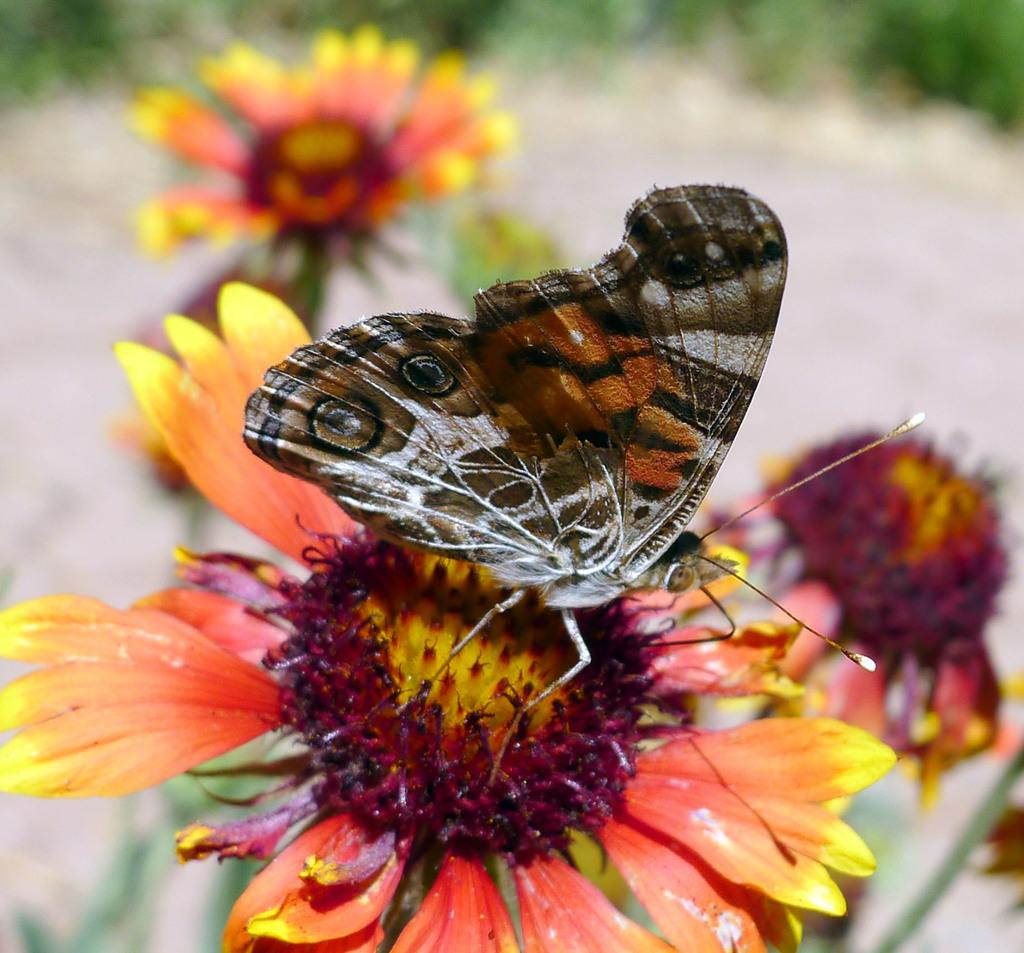What type of living organisms can be seen in the image? There are flowers and a butterfly in the image. What is the primary subject of the image? The primary subject of the image is the butterfly. How would you describe the background of the image? The background of the image is blurred. What type of print can be seen on the butterfly's wings in the image? There is no print visible on the butterfly's wings in the image; they appear to be a solid color. How much attention does the butterfly demand from the viewer in the image? The butterfly is the primary subject of the image, so it demands a significant amount of attention from the viewer. 